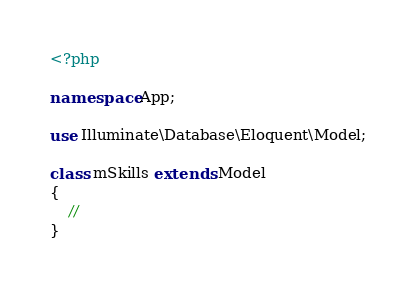<code> <loc_0><loc_0><loc_500><loc_500><_PHP_><?php

namespace App;

use Illuminate\Database\Eloquent\Model;

class mSkills extends Model
{
    //
}
</code> 